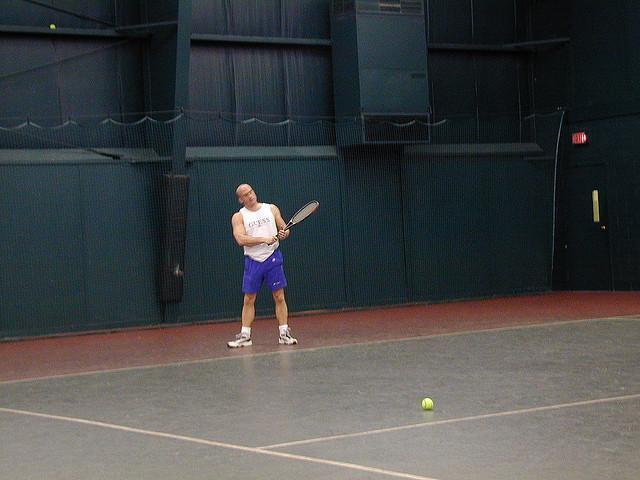How many tennis balls are visible in this picture?
Give a very brief answer. 1. 